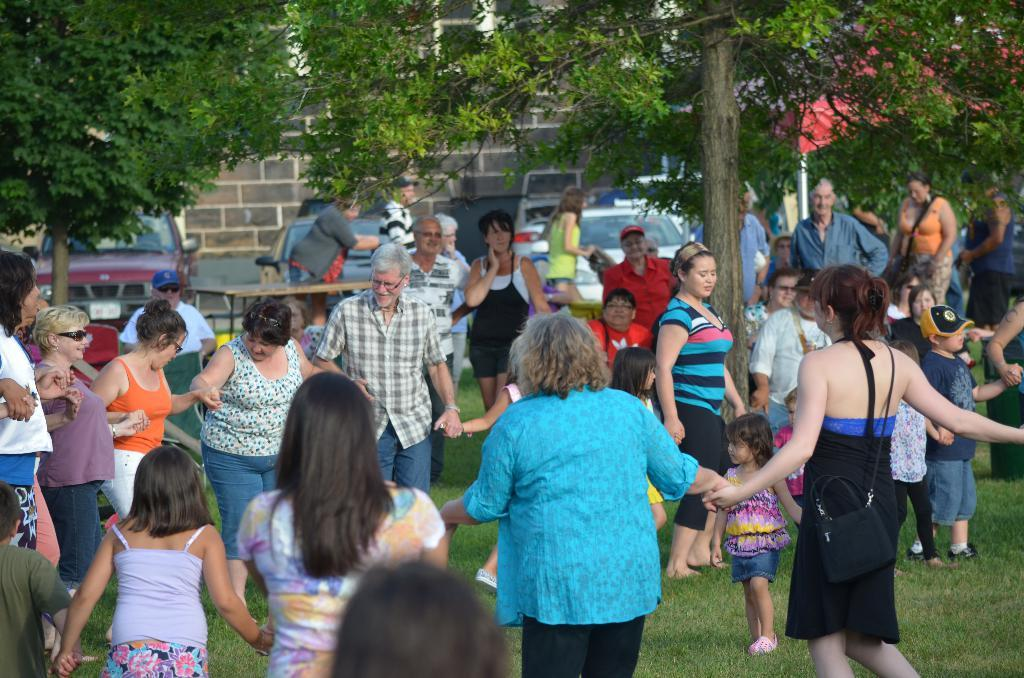What is the main subject in the foreground of the picture? There is a crowd in the foreground of the picture. What are the people in the crowd doing? The people in the crowd are holding hands. Where is the crowd standing? The crowd is standing on the grass. Can you describe the background of the picture? There are persons, a table, cars, a wall, and trees in the background of the picture. What type of paint is being used by the people in the crowd? There is no paint visible in the image, and the people in the crowd are holding hands, not using paint. Can you tell me how many toothpaste tubes are on the table in the background? There is no toothpaste present in the image, and the table in the background is not shown in enough detail to determine the presence of toothpaste tubes. 